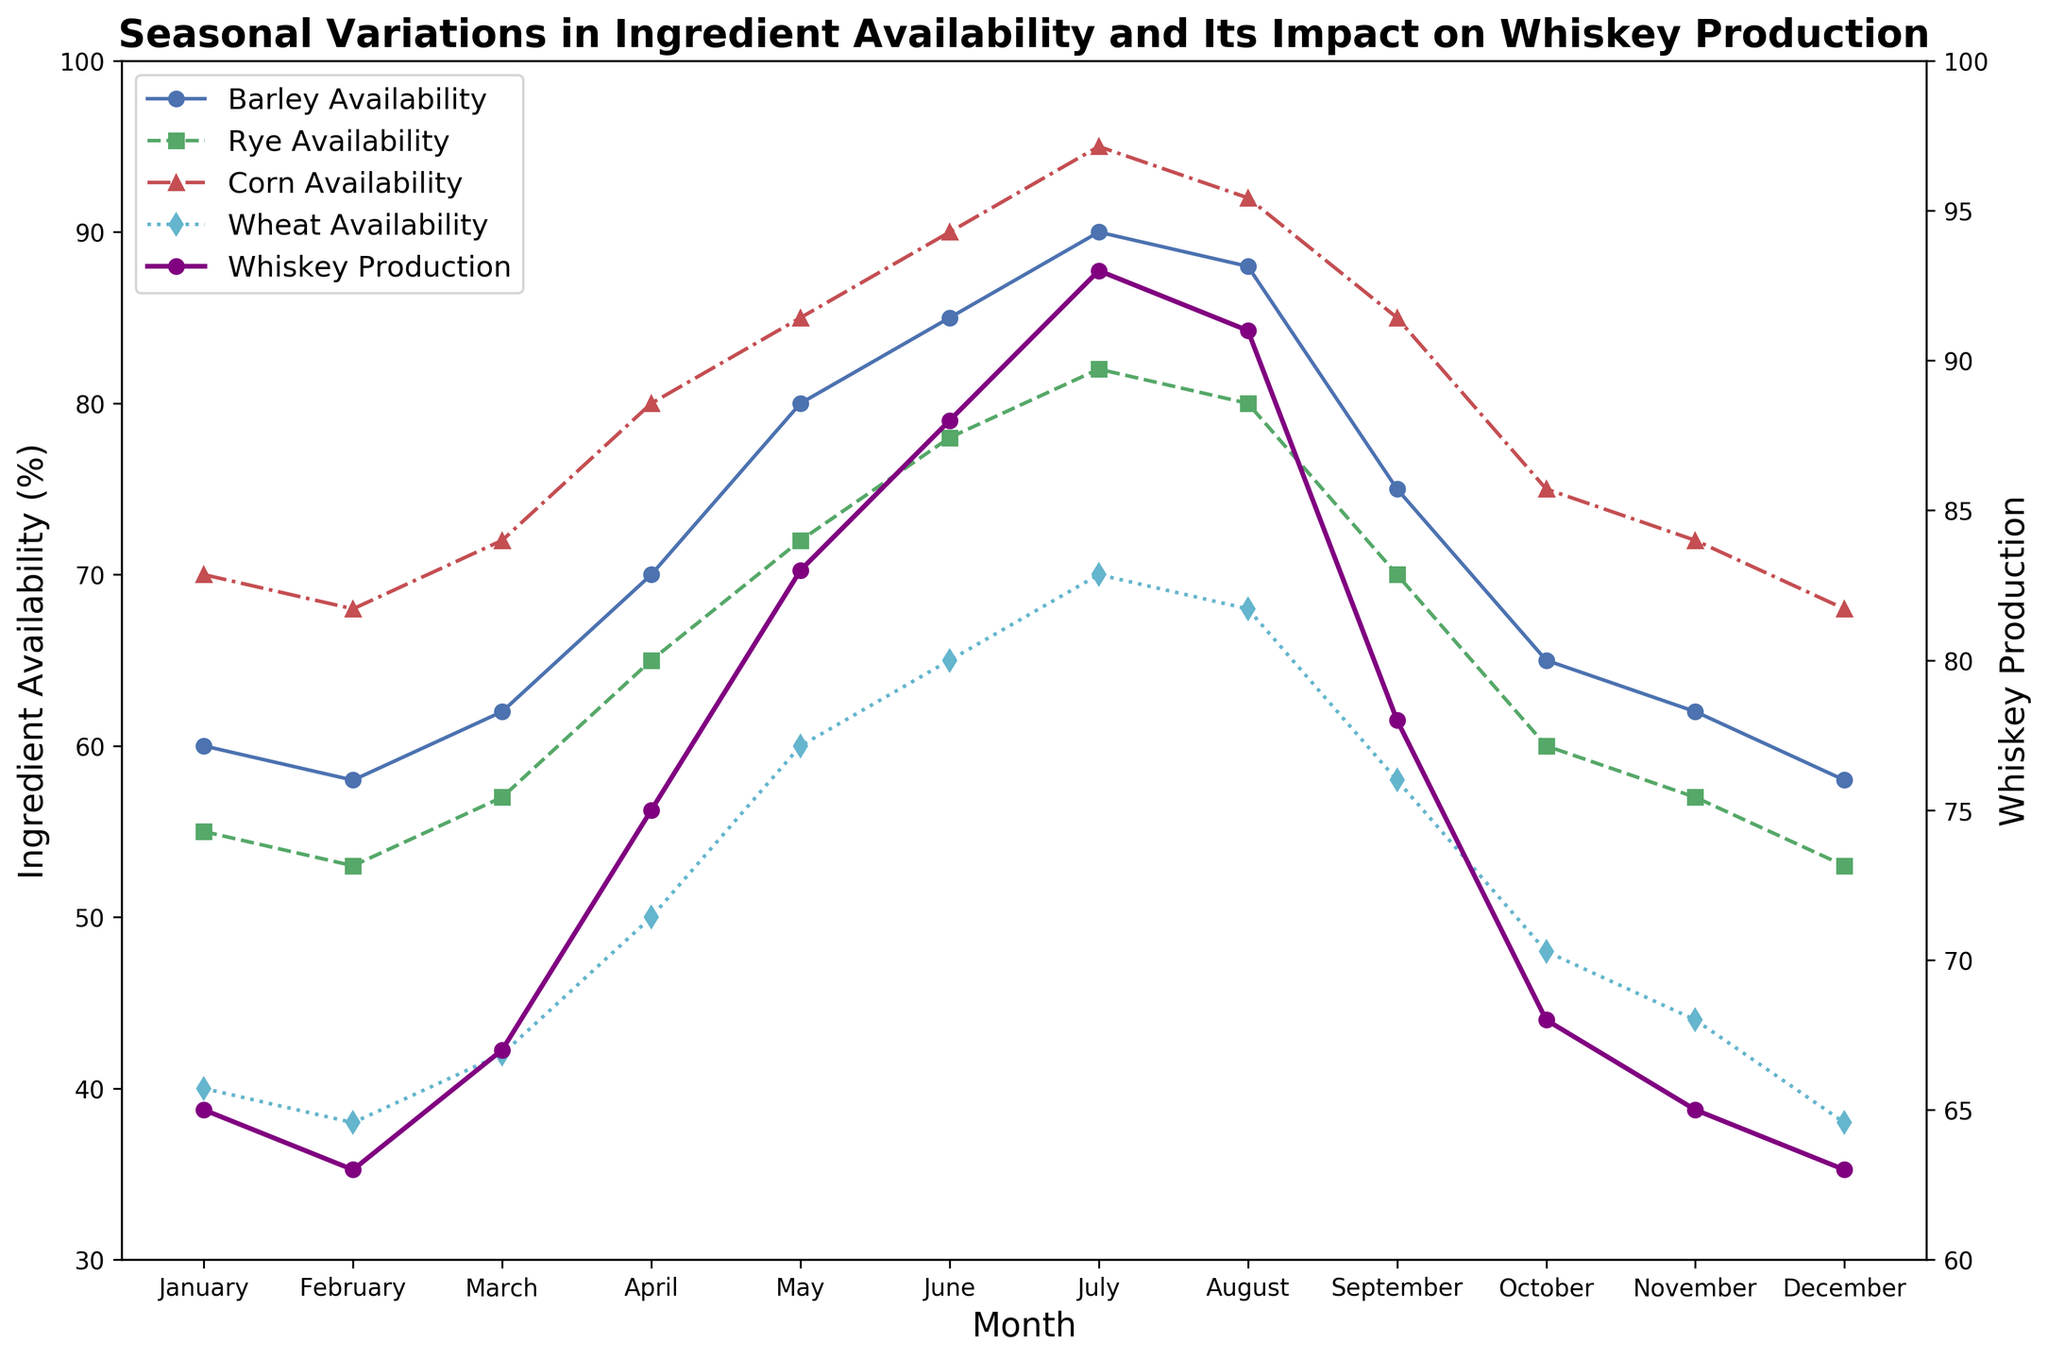what month has the highest barley availability and what is its value? The month with the highest barley availability can be observed by looking at the peak of the blue line (Barley Availability) on the plot. This occurs in July. The value of barley availability in July is 90.
Answer: July, 90 how does rye availability in January compare to March? To compare rye availability between January and March, we look at the data points on the green dashed line (Rye Availability). In January, rye availability is 55, and in March, it is 57. So, Rye Availability in March is slightly higher than in January by 2.
Answer: March is higher by 2 what is the difference in whiskey production between August and October? To find the difference in whiskey production between August and October, look at the purple line (Whiskey Production). The whiskey production in August is 91, and in October, it is 68. The difference is 91 - 68 = 23.
Answer: 23 which month has the lowest corn availability and what impact does it have on whiskey production? The lowest corn availability can be determined by looking at the red dash-dotted line (Corn Availability), which reaches its minimum in February and December, both at 68. In these months, whiskey production is 63. Lower corn availability coincides with relatively lower whiskey production, suggesting a potential dependency.
Answer: February and December, whiskey production is 63 what is the average availability of wheat from March to May? To calculate the average availability of wheat from March to May, we sum the values for March (42), April (50), and May (60) and then divide by 3. (42 + 50 + 60) / 3 = 152 / 3 = 50.67.
Answer: 50.67 during which month does the availability of all four ingredients reach their peak, and what is the whiskey production that month? To find when all four ingredients reach their peak simultaneously, observe the lines for Barley (blue), Rye (green), Corn (red), and Wheat (cyan). None of the months show all ingredients peaking together. The closest is July, with high but not peak values for each. In July, whiskey production is at its highest, which is 93.
Answer: All ingredients do not peak simultaneously; closest is July with whiskey production at 93 compare the trend of barley and rye availability over the year – are their patterns similar or different? To compare the trends for barley and rye, observe the blue (Barley) and green (Rye) lines. Both lines increase from January to July, then decrease towards December. The patterns are similar, though barley peaks higher than rye.
Answer: Similar patterns calculate the total availability of corn over the first half of the year (January to June). Sum the values of corn availability for January (70), February (68), March (72), April (80), May (85), and June (90). The total is 70 + 68 + 72 + 80 + 85 + 90 = 465.
Answer: 465 what is the relationship between barley availability and whiskey production in June? To determine the relationship in June, observe the blue line (Barley Availability) and purple line (Whiskey Production). Barley availability is 85, and whiskey production is 88, indicating a strong correlation between higher barley availability and increased whiskey production.
Answer: Barley availability is 85, whiskey production is 88 